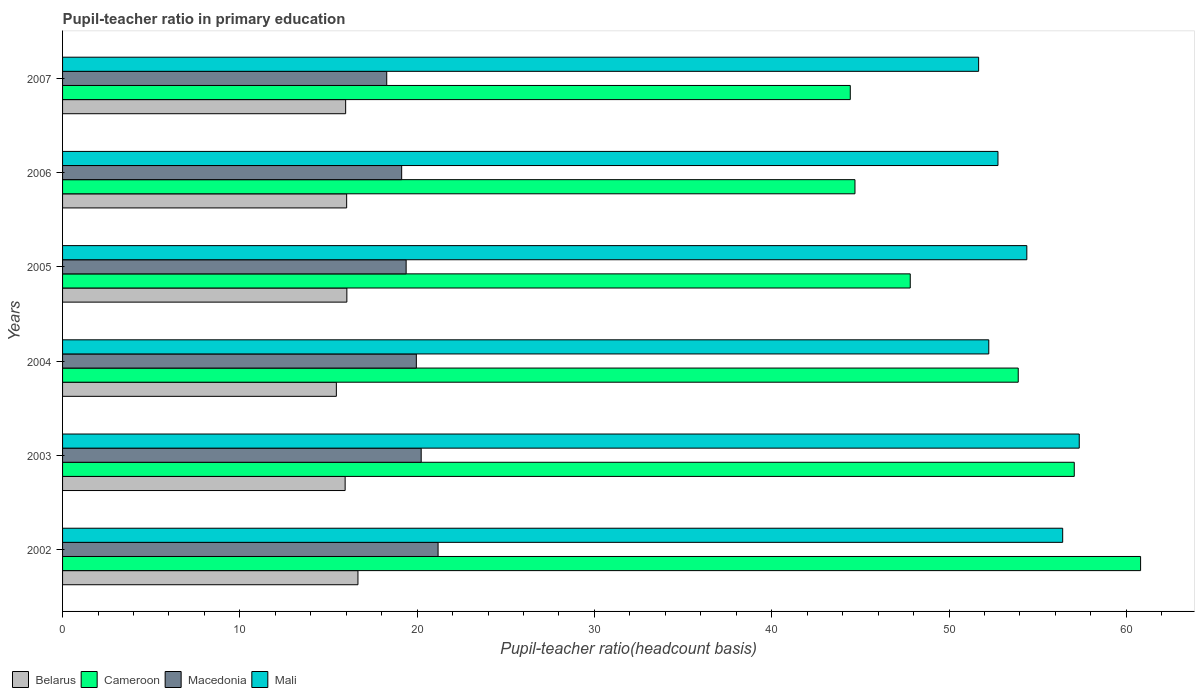How many different coloured bars are there?
Your answer should be compact. 4. How many groups of bars are there?
Make the answer very short. 6. How many bars are there on the 1st tick from the top?
Make the answer very short. 4. How many bars are there on the 3rd tick from the bottom?
Your response must be concise. 4. What is the label of the 6th group of bars from the top?
Keep it short and to the point. 2002. In how many cases, is the number of bars for a given year not equal to the number of legend labels?
Offer a very short reply. 0. What is the pupil-teacher ratio in primary education in Belarus in 2007?
Your answer should be very brief. 15.97. Across all years, what is the maximum pupil-teacher ratio in primary education in Mali?
Ensure brevity in your answer.  57.34. Across all years, what is the minimum pupil-teacher ratio in primary education in Macedonia?
Your response must be concise. 18.28. What is the total pupil-teacher ratio in primary education in Belarus in the graph?
Keep it short and to the point. 96.07. What is the difference between the pupil-teacher ratio in primary education in Cameroon in 2002 and that in 2004?
Your answer should be very brief. 6.9. What is the difference between the pupil-teacher ratio in primary education in Mali in 2004 and the pupil-teacher ratio in primary education in Cameroon in 2005?
Give a very brief answer. 4.43. What is the average pupil-teacher ratio in primary education in Cameroon per year?
Make the answer very short. 51.45. In the year 2004, what is the difference between the pupil-teacher ratio in primary education in Mali and pupil-teacher ratio in primary education in Belarus?
Your answer should be compact. 36.8. In how many years, is the pupil-teacher ratio in primary education in Belarus greater than 22 ?
Your response must be concise. 0. What is the ratio of the pupil-teacher ratio in primary education in Macedonia in 2002 to that in 2003?
Make the answer very short. 1.05. What is the difference between the highest and the second highest pupil-teacher ratio in primary education in Mali?
Offer a terse response. 0.93. What is the difference between the highest and the lowest pupil-teacher ratio in primary education in Mali?
Your answer should be very brief. 5.68. Is it the case that in every year, the sum of the pupil-teacher ratio in primary education in Cameroon and pupil-teacher ratio in primary education in Macedonia is greater than the sum of pupil-teacher ratio in primary education in Belarus and pupil-teacher ratio in primary education in Mali?
Give a very brief answer. Yes. What does the 1st bar from the top in 2003 represents?
Your response must be concise. Mali. What does the 2nd bar from the bottom in 2003 represents?
Your answer should be very brief. Cameroon. Is it the case that in every year, the sum of the pupil-teacher ratio in primary education in Macedonia and pupil-teacher ratio in primary education in Cameroon is greater than the pupil-teacher ratio in primary education in Mali?
Provide a short and direct response. Yes. What is the difference between two consecutive major ticks on the X-axis?
Offer a very short reply. 10. Are the values on the major ticks of X-axis written in scientific E-notation?
Provide a short and direct response. No. Does the graph contain any zero values?
Your answer should be very brief. No. How many legend labels are there?
Ensure brevity in your answer.  4. How are the legend labels stacked?
Ensure brevity in your answer.  Horizontal. What is the title of the graph?
Provide a succinct answer. Pupil-teacher ratio in primary education. Does "Comoros" appear as one of the legend labels in the graph?
Offer a very short reply. No. What is the label or title of the X-axis?
Keep it short and to the point. Pupil-teacher ratio(headcount basis). What is the label or title of the Y-axis?
Make the answer very short. Years. What is the Pupil-teacher ratio(headcount basis) of Belarus in 2002?
Your response must be concise. 16.66. What is the Pupil-teacher ratio(headcount basis) in Cameroon in 2002?
Offer a terse response. 60.8. What is the Pupil-teacher ratio(headcount basis) in Macedonia in 2002?
Give a very brief answer. 21.18. What is the Pupil-teacher ratio(headcount basis) of Mali in 2002?
Give a very brief answer. 56.41. What is the Pupil-teacher ratio(headcount basis) of Belarus in 2003?
Offer a terse response. 15.94. What is the Pupil-teacher ratio(headcount basis) in Cameroon in 2003?
Your answer should be very brief. 57.06. What is the Pupil-teacher ratio(headcount basis) in Macedonia in 2003?
Your answer should be very brief. 20.23. What is the Pupil-teacher ratio(headcount basis) in Mali in 2003?
Give a very brief answer. 57.34. What is the Pupil-teacher ratio(headcount basis) of Belarus in 2004?
Provide a succinct answer. 15.44. What is the Pupil-teacher ratio(headcount basis) of Cameroon in 2004?
Provide a short and direct response. 53.9. What is the Pupil-teacher ratio(headcount basis) in Macedonia in 2004?
Offer a very short reply. 19.95. What is the Pupil-teacher ratio(headcount basis) of Mali in 2004?
Offer a terse response. 52.24. What is the Pupil-teacher ratio(headcount basis) in Belarus in 2005?
Make the answer very short. 16.04. What is the Pupil-teacher ratio(headcount basis) in Cameroon in 2005?
Your response must be concise. 47.81. What is the Pupil-teacher ratio(headcount basis) of Macedonia in 2005?
Offer a very short reply. 19.38. What is the Pupil-teacher ratio(headcount basis) in Mali in 2005?
Provide a short and direct response. 54.39. What is the Pupil-teacher ratio(headcount basis) of Belarus in 2006?
Your response must be concise. 16.02. What is the Pupil-teacher ratio(headcount basis) of Cameroon in 2006?
Make the answer very short. 44.69. What is the Pupil-teacher ratio(headcount basis) in Macedonia in 2006?
Offer a very short reply. 19.13. What is the Pupil-teacher ratio(headcount basis) in Mali in 2006?
Offer a terse response. 52.76. What is the Pupil-teacher ratio(headcount basis) in Belarus in 2007?
Provide a short and direct response. 15.97. What is the Pupil-teacher ratio(headcount basis) in Cameroon in 2007?
Your response must be concise. 44.43. What is the Pupil-teacher ratio(headcount basis) of Macedonia in 2007?
Keep it short and to the point. 18.28. What is the Pupil-teacher ratio(headcount basis) in Mali in 2007?
Make the answer very short. 51.67. Across all years, what is the maximum Pupil-teacher ratio(headcount basis) in Belarus?
Ensure brevity in your answer.  16.66. Across all years, what is the maximum Pupil-teacher ratio(headcount basis) of Cameroon?
Provide a short and direct response. 60.8. Across all years, what is the maximum Pupil-teacher ratio(headcount basis) of Macedonia?
Make the answer very short. 21.18. Across all years, what is the maximum Pupil-teacher ratio(headcount basis) in Mali?
Provide a short and direct response. 57.34. Across all years, what is the minimum Pupil-teacher ratio(headcount basis) in Belarus?
Provide a short and direct response. 15.44. Across all years, what is the minimum Pupil-teacher ratio(headcount basis) of Cameroon?
Keep it short and to the point. 44.43. Across all years, what is the minimum Pupil-teacher ratio(headcount basis) in Macedonia?
Provide a short and direct response. 18.28. Across all years, what is the minimum Pupil-teacher ratio(headcount basis) in Mali?
Your answer should be compact. 51.67. What is the total Pupil-teacher ratio(headcount basis) in Belarus in the graph?
Offer a very short reply. 96.07. What is the total Pupil-teacher ratio(headcount basis) in Cameroon in the graph?
Keep it short and to the point. 308.71. What is the total Pupil-teacher ratio(headcount basis) in Macedonia in the graph?
Your answer should be very brief. 118.15. What is the total Pupil-teacher ratio(headcount basis) of Mali in the graph?
Give a very brief answer. 324.81. What is the difference between the Pupil-teacher ratio(headcount basis) of Belarus in 2002 and that in 2003?
Provide a short and direct response. 0.72. What is the difference between the Pupil-teacher ratio(headcount basis) of Cameroon in 2002 and that in 2003?
Keep it short and to the point. 3.74. What is the difference between the Pupil-teacher ratio(headcount basis) in Macedonia in 2002 and that in 2003?
Provide a succinct answer. 0.95. What is the difference between the Pupil-teacher ratio(headcount basis) in Mali in 2002 and that in 2003?
Make the answer very short. -0.93. What is the difference between the Pupil-teacher ratio(headcount basis) of Belarus in 2002 and that in 2004?
Your response must be concise. 1.22. What is the difference between the Pupil-teacher ratio(headcount basis) of Cameroon in 2002 and that in 2004?
Your answer should be compact. 6.9. What is the difference between the Pupil-teacher ratio(headcount basis) in Macedonia in 2002 and that in 2004?
Provide a short and direct response. 1.23. What is the difference between the Pupil-teacher ratio(headcount basis) of Mali in 2002 and that in 2004?
Offer a very short reply. 4.17. What is the difference between the Pupil-teacher ratio(headcount basis) of Belarus in 2002 and that in 2005?
Provide a succinct answer. 0.63. What is the difference between the Pupil-teacher ratio(headcount basis) in Cameroon in 2002 and that in 2005?
Your answer should be very brief. 12.99. What is the difference between the Pupil-teacher ratio(headcount basis) in Macedonia in 2002 and that in 2005?
Provide a short and direct response. 1.8. What is the difference between the Pupil-teacher ratio(headcount basis) in Mali in 2002 and that in 2005?
Your answer should be compact. 2.02. What is the difference between the Pupil-teacher ratio(headcount basis) of Belarus in 2002 and that in 2006?
Make the answer very short. 0.64. What is the difference between the Pupil-teacher ratio(headcount basis) of Cameroon in 2002 and that in 2006?
Offer a very short reply. 16.11. What is the difference between the Pupil-teacher ratio(headcount basis) of Macedonia in 2002 and that in 2006?
Provide a short and direct response. 2.05. What is the difference between the Pupil-teacher ratio(headcount basis) in Mali in 2002 and that in 2006?
Offer a terse response. 3.65. What is the difference between the Pupil-teacher ratio(headcount basis) of Belarus in 2002 and that in 2007?
Your answer should be compact. 0.69. What is the difference between the Pupil-teacher ratio(headcount basis) in Cameroon in 2002 and that in 2007?
Keep it short and to the point. 16.37. What is the difference between the Pupil-teacher ratio(headcount basis) in Macedonia in 2002 and that in 2007?
Provide a succinct answer. 2.9. What is the difference between the Pupil-teacher ratio(headcount basis) in Mali in 2002 and that in 2007?
Make the answer very short. 4.74. What is the difference between the Pupil-teacher ratio(headcount basis) in Belarus in 2003 and that in 2004?
Make the answer very short. 0.5. What is the difference between the Pupil-teacher ratio(headcount basis) in Cameroon in 2003 and that in 2004?
Your answer should be compact. 3.16. What is the difference between the Pupil-teacher ratio(headcount basis) in Macedonia in 2003 and that in 2004?
Ensure brevity in your answer.  0.27. What is the difference between the Pupil-teacher ratio(headcount basis) in Mali in 2003 and that in 2004?
Your response must be concise. 5.1. What is the difference between the Pupil-teacher ratio(headcount basis) of Belarus in 2003 and that in 2005?
Your answer should be very brief. -0.1. What is the difference between the Pupil-teacher ratio(headcount basis) in Cameroon in 2003 and that in 2005?
Keep it short and to the point. 9.25. What is the difference between the Pupil-teacher ratio(headcount basis) in Macedonia in 2003 and that in 2005?
Your answer should be compact. 0.85. What is the difference between the Pupil-teacher ratio(headcount basis) of Mali in 2003 and that in 2005?
Ensure brevity in your answer.  2.96. What is the difference between the Pupil-teacher ratio(headcount basis) in Belarus in 2003 and that in 2006?
Provide a short and direct response. -0.09. What is the difference between the Pupil-teacher ratio(headcount basis) of Cameroon in 2003 and that in 2006?
Your answer should be very brief. 12.37. What is the difference between the Pupil-teacher ratio(headcount basis) in Macedonia in 2003 and that in 2006?
Make the answer very short. 1.1. What is the difference between the Pupil-teacher ratio(headcount basis) of Mali in 2003 and that in 2006?
Give a very brief answer. 4.58. What is the difference between the Pupil-teacher ratio(headcount basis) of Belarus in 2003 and that in 2007?
Provide a short and direct response. -0.03. What is the difference between the Pupil-teacher ratio(headcount basis) of Cameroon in 2003 and that in 2007?
Offer a very short reply. 12.63. What is the difference between the Pupil-teacher ratio(headcount basis) in Macedonia in 2003 and that in 2007?
Ensure brevity in your answer.  1.94. What is the difference between the Pupil-teacher ratio(headcount basis) of Mali in 2003 and that in 2007?
Your answer should be very brief. 5.68. What is the difference between the Pupil-teacher ratio(headcount basis) in Belarus in 2004 and that in 2005?
Ensure brevity in your answer.  -0.59. What is the difference between the Pupil-teacher ratio(headcount basis) of Cameroon in 2004 and that in 2005?
Your response must be concise. 6.09. What is the difference between the Pupil-teacher ratio(headcount basis) of Macedonia in 2004 and that in 2005?
Give a very brief answer. 0.58. What is the difference between the Pupil-teacher ratio(headcount basis) of Mali in 2004 and that in 2005?
Offer a very short reply. -2.15. What is the difference between the Pupil-teacher ratio(headcount basis) of Belarus in 2004 and that in 2006?
Offer a terse response. -0.58. What is the difference between the Pupil-teacher ratio(headcount basis) of Cameroon in 2004 and that in 2006?
Provide a short and direct response. 9.21. What is the difference between the Pupil-teacher ratio(headcount basis) of Macedonia in 2004 and that in 2006?
Make the answer very short. 0.83. What is the difference between the Pupil-teacher ratio(headcount basis) in Mali in 2004 and that in 2006?
Ensure brevity in your answer.  -0.52. What is the difference between the Pupil-teacher ratio(headcount basis) of Belarus in 2004 and that in 2007?
Your answer should be compact. -0.52. What is the difference between the Pupil-teacher ratio(headcount basis) of Cameroon in 2004 and that in 2007?
Your answer should be very brief. 9.47. What is the difference between the Pupil-teacher ratio(headcount basis) in Macedonia in 2004 and that in 2007?
Your response must be concise. 1.67. What is the difference between the Pupil-teacher ratio(headcount basis) in Mali in 2004 and that in 2007?
Provide a short and direct response. 0.57. What is the difference between the Pupil-teacher ratio(headcount basis) in Belarus in 2005 and that in 2006?
Give a very brief answer. 0.01. What is the difference between the Pupil-teacher ratio(headcount basis) in Cameroon in 2005 and that in 2006?
Keep it short and to the point. 3.12. What is the difference between the Pupil-teacher ratio(headcount basis) of Macedonia in 2005 and that in 2006?
Provide a succinct answer. 0.25. What is the difference between the Pupil-teacher ratio(headcount basis) of Mali in 2005 and that in 2006?
Keep it short and to the point. 1.63. What is the difference between the Pupil-teacher ratio(headcount basis) of Belarus in 2005 and that in 2007?
Your answer should be compact. 0.07. What is the difference between the Pupil-teacher ratio(headcount basis) in Cameroon in 2005 and that in 2007?
Your answer should be compact. 3.38. What is the difference between the Pupil-teacher ratio(headcount basis) in Macedonia in 2005 and that in 2007?
Ensure brevity in your answer.  1.09. What is the difference between the Pupil-teacher ratio(headcount basis) of Mali in 2005 and that in 2007?
Ensure brevity in your answer.  2.72. What is the difference between the Pupil-teacher ratio(headcount basis) in Belarus in 2006 and that in 2007?
Your response must be concise. 0.06. What is the difference between the Pupil-teacher ratio(headcount basis) in Cameroon in 2006 and that in 2007?
Offer a very short reply. 0.26. What is the difference between the Pupil-teacher ratio(headcount basis) of Macedonia in 2006 and that in 2007?
Your answer should be very brief. 0.84. What is the difference between the Pupil-teacher ratio(headcount basis) in Mali in 2006 and that in 2007?
Provide a short and direct response. 1.09. What is the difference between the Pupil-teacher ratio(headcount basis) of Belarus in 2002 and the Pupil-teacher ratio(headcount basis) of Cameroon in 2003?
Keep it short and to the point. -40.4. What is the difference between the Pupil-teacher ratio(headcount basis) in Belarus in 2002 and the Pupil-teacher ratio(headcount basis) in Macedonia in 2003?
Keep it short and to the point. -3.57. What is the difference between the Pupil-teacher ratio(headcount basis) in Belarus in 2002 and the Pupil-teacher ratio(headcount basis) in Mali in 2003?
Make the answer very short. -40.68. What is the difference between the Pupil-teacher ratio(headcount basis) of Cameroon in 2002 and the Pupil-teacher ratio(headcount basis) of Macedonia in 2003?
Your response must be concise. 40.58. What is the difference between the Pupil-teacher ratio(headcount basis) of Cameroon in 2002 and the Pupil-teacher ratio(headcount basis) of Mali in 2003?
Offer a terse response. 3.46. What is the difference between the Pupil-teacher ratio(headcount basis) in Macedonia in 2002 and the Pupil-teacher ratio(headcount basis) in Mali in 2003?
Make the answer very short. -36.16. What is the difference between the Pupil-teacher ratio(headcount basis) of Belarus in 2002 and the Pupil-teacher ratio(headcount basis) of Cameroon in 2004?
Offer a very short reply. -37.24. What is the difference between the Pupil-teacher ratio(headcount basis) in Belarus in 2002 and the Pupil-teacher ratio(headcount basis) in Macedonia in 2004?
Ensure brevity in your answer.  -3.29. What is the difference between the Pupil-teacher ratio(headcount basis) of Belarus in 2002 and the Pupil-teacher ratio(headcount basis) of Mali in 2004?
Provide a short and direct response. -35.58. What is the difference between the Pupil-teacher ratio(headcount basis) in Cameroon in 2002 and the Pupil-teacher ratio(headcount basis) in Macedonia in 2004?
Your response must be concise. 40.85. What is the difference between the Pupil-teacher ratio(headcount basis) of Cameroon in 2002 and the Pupil-teacher ratio(headcount basis) of Mali in 2004?
Provide a succinct answer. 8.56. What is the difference between the Pupil-teacher ratio(headcount basis) in Macedonia in 2002 and the Pupil-teacher ratio(headcount basis) in Mali in 2004?
Offer a very short reply. -31.06. What is the difference between the Pupil-teacher ratio(headcount basis) of Belarus in 2002 and the Pupil-teacher ratio(headcount basis) of Cameroon in 2005?
Keep it short and to the point. -31.15. What is the difference between the Pupil-teacher ratio(headcount basis) in Belarus in 2002 and the Pupil-teacher ratio(headcount basis) in Macedonia in 2005?
Offer a very short reply. -2.72. What is the difference between the Pupil-teacher ratio(headcount basis) in Belarus in 2002 and the Pupil-teacher ratio(headcount basis) in Mali in 2005?
Make the answer very short. -37.73. What is the difference between the Pupil-teacher ratio(headcount basis) in Cameroon in 2002 and the Pupil-teacher ratio(headcount basis) in Macedonia in 2005?
Make the answer very short. 41.43. What is the difference between the Pupil-teacher ratio(headcount basis) of Cameroon in 2002 and the Pupil-teacher ratio(headcount basis) of Mali in 2005?
Your answer should be compact. 6.42. What is the difference between the Pupil-teacher ratio(headcount basis) of Macedonia in 2002 and the Pupil-teacher ratio(headcount basis) of Mali in 2005?
Ensure brevity in your answer.  -33.21. What is the difference between the Pupil-teacher ratio(headcount basis) in Belarus in 2002 and the Pupil-teacher ratio(headcount basis) in Cameroon in 2006?
Keep it short and to the point. -28.03. What is the difference between the Pupil-teacher ratio(headcount basis) in Belarus in 2002 and the Pupil-teacher ratio(headcount basis) in Macedonia in 2006?
Keep it short and to the point. -2.47. What is the difference between the Pupil-teacher ratio(headcount basis) of Belarus in 2002 and the Pupil-teacher ratio(headcount basis) of Mali in 2006?
Your answer should be very brief. -36.1. What is the difference between the Pupil-teacher ratio(headcount basis) in Cameroon in 2002 and the Pupil-teacher ratio(headcount basis) in Macedonia in 2006?
Provide a succinct answer. 41.68. What is the difference between the Pupil-teacher ratio(headcount basis) in Cameroon in 2002 and the Pupil-teacher ratio(headcount basis) in Mali in 2006?
Ensure brevity in your answer.  8.04. What is the difference between the Pupil-teacher ratio(headcount basis) of Macedonia in 2002 and the Pupil-teacher ratio(headcount basis) of Mali in 2006?
Your response must be concise. -31.58. What is the difference between the Pupil-teacher ratio(headcount basis) of Belarus in 2002 and the Pupil-teacher ratio(headcount basis) of Cameroon in 2007?
Your answer should be very brief. -27.77. What is the difference between the Pupil-teacher ratio(headcount basis) in Belarus in 2002 and the Pupil-teacher ratio(headcount basis) in Macedonia in 2007?
Your response must be concise. -1.62. What is the difference between the Pupil-teacher ratio(headcount basis) of Belarus in 2002 and the Pupil-teacher ratio(headcount basis) of Mali in 2007?
Your response must be concise. -35.01. What is the difference between the Pupil-teacher ratio(headcount basis) of Cameroon in 2002 and the Pupil-teacher ratio(headcount basis) of Macedonia in 2007?
Your response must be concise. 42.52. What is the difference between the Pupil-teacher ratio(headcount basis) of Cameroon in 2002 and the Pupil-teacher ratio(headcount basis) of Mali in 2007?
Make the answer very short. 9.14. What is the difference between the Pupil-teacher ratio(headcount basis) in Macedonia in 2002 and the Pupil-teacher ratio(headcount basis) in Mali in 2007?
Keep it short and to the point. -30.49. What is the difference between the Pupil-teacher ratio(headcount basis) in Belarus in 2003 and the Pupil-teacher ratio(headcount basis) in Cameroon in 2004?
Your answer should be compact. -37.96. What is the difference between the Pupil-teacher ratio(headcount basis) of Belarus in 2003 and the Pupil-teacher ratio(headcount basis) of Macedonia in 2004?
Your response must be concise. -4.02. What is the difference between the Pupil-teacher ratio(headcount basis) in Belarus in 2003 and the Pupil-teacher ratio(headcount basis) in Mali in 2004?
Ensure brevity in your answer.  -36.3. What is the difference between the Pupil-teacher ratio(headcount basis) in Cameroon in 2003 and the Pupil-teacher ratio(headcount basis) in Macedonia in 2004?
Your answer should be compact. 37.11. What is the difference between the Pupil-teacher ratio(headcount basis) in Cameroon in 2003 and the Pupil-teacher ratio(headcount basis) in Mali in 2004?
Your answer should be compact. 4.82. What is the difference between the Pupil-teacher ratio(headcount basis) in Macedonia in 2003 and the Pupil-teacher ratio(headcount basis) in Mali in 2004?
Keep it short and to the point. -32.01. What is the difference between the Pupil-teacher ratio(headcount basis) in Belarus in 2003 and the Pupil-teacher ratio(headcount basis) in Cameroon in 2005?
Provide a succinct answer. -31.87. What is the difference between the Pupil-teacher ratio(headcount basis) of Belarus in 2003 and the Pupil-teacher ratio(headcount basis) of Macedonia in 2005?
Provide a succinct answer. -3.44. What is the difference between the Pupil-teacher ratio(headcount basis) of Belarus in 2003 and the Pupil-teacher ratio(headcount basis) of Mali in 2005?
Give a very brief answer. -38.45. What is the difference between the Pupil-teacher ratio(headcount basis) in Cameroon in 2003 and the Pupil-teacher ratio(headcount basis) in Macedonia in 2005?
Your response must be concise. 37.69. What is the difference between the Pupil-teacher ratio(headcount basis) in Cameroon in 2003 and the Pupil-teacher ratio(headcount basis) in Mali in 2005?
Offer a terse response. 2.68. What is the difference between the Pupil-teacher ratio(headcount basis) of Macedonia in 2003 and the Pupil-teacher ratio(headcount basis) of Mali in 2005?
Offer a very short reply. -34.16. What is the difference between the Pupil-teacher ratio(headcount basis) in Belarus in 2003 and the Pupil-teacher ratio(headcount basis) in Cameroon in 2006?
Your answer should be very brief. -28.76. What is the difference between the Pupil-teacher ratio(headcount basis) in Belarus in 2003 and the Pupil-teacher ratio(headcount basis) in Macedonia in 2006?
Your response must be concise. -3.19. What is the difference between the Pupil-teacher ratio(headcount basis) of Belarus in 2003 and the Pupil-teacher ratio(headcount basis) of Mali in 2006?
Your response must be concise. -36.82. What is the difference between the Pupil-teacher ratio(headcount basis) of Cameroon in 2003 and the Pupil-teacher ratio(headcount basis) of Macedonia in 2006?
Keep it short and to the point. 37.94. What is the difference between the Pupil-teacher ratio(headcount basis) in Cameroon in 2003 and the Pupil-teacher ratio(headcount basis) in Mali in 2006?
Keep it short and to the point. 4.3. What is the difference between the Pupil-teacher ratio(headcount basis) of Macedonia in 2003 and the Pupil-teacher ratio(headcount basis) of Mali in 2006?
Your response must be concise. -32.53. What is the difference between the Pupil-teacher ratio(headcount basis) of Belarus in 2003 and the Pupil-teacher ratio(headcount basis) of Cameroon in 2007?
Ensure brevity in your answer.  -28.49. What is the difference between the Pupil-teacher ratio(headcount basis) of Belarus in 2003 and the Pupil-teacher ratio(headcount basis) of Macedonia in 2007?
Keep it short and to the point. -2.35. What is the difference between the Pupil-teacher ratio(headcount basis) in Belarus in 2003 and the Pupil-teacher ratio(headcount basis) in Mali in 2007?
Provide a succinct answer. -35.73. What is the difference between the Pupil-teacher ratio(headcount basis) in Cameroon in 2003 and the Pupil-teacher ratio(headcount basis) in Macedonia in 2007?
Offer a very short reply. 38.78. What is the difference between the Pupil-teacher ratio(headcount basis) in Cameroon in 2003 and the Pupil-teacher ratio(headcount basis) in Mali in 2007?
Your answer should be very brief. 5.39. What is the difference between the Pupil-teacher ratio(headcount basis) of Macedonia in 2003 and the Pupil-teacher ratio(headcount basis) of Mali in 2007?
Provide a short and direct response. -31.44. What is the difference between the Pupil-teacher ratio(headcount basis) of Belarus in 2004 and the Pupil-teacher ratio(headcount basis) of Cameroon in 2005?
Your answer should be very brief. -32.37. What is the difference between the Pupil-teacher ratio(headcount basis) of Belarus in 2004 and the Pupil-teacher ratio(headcount basis) of Macedonia in 2005?
Keep it short and to the point. -3.94. What is the difference between the Pupil-teacher ratio(headcount basis) of Belarus in 2004 and the Pupil-teacher ratio(headcount basis) of Mali in 2005?
Make the answer very short. -38.95. What is the difference between the Pupil-teacher ratio(headcount basis) in Cameroon in 2004 and the Pupil-teacher ratio(headcount basis) in Macedonia in 2005?
Keep it short and to the point. 34.52. What is the difference between the Pupil-teacher ratio(headcount basis) in Cameroon in 2004 and the Pupil-teacher ratio(headcount basis) in Mali in 2005?
Your answer should be very brief. -0.49. What is the difference between the Pupil-teacher ratio(headcount basis) of Macedonia in 2004 and the Pupil-teacher ratio(headcount basis) of Mali in 2005?
Offer a terse response. -34.43. What is the difference between the Pupil-teacher ratio(headcount basis) of Belarus in 2004 and the Pupil-teacher ratio(headcount basis) of Cameroon in 2006?
Your answer should be very brief. -29.25. What is the difference between the Pupil-teacher ratio(headcount basis) in Belarus in 2004 and the Pupil-teacher ratio(headcount basis) in Macedonia in 2006?
Your answer should be very brief. -3.68. What is the difference between the Pupil-teacher ratio(headcount basis) of Belarus in 2004 and the Pupil-teacher ratio(headcount basis) of Mali in 2006?
Offer a terse response. -37.32. What is the difference between the Pupil-teacher ratio(headcount basis) in Cameroon in 2004 and the Pupil-teacher ratio(headcount basis) in Macedonia in 2006?
Give a very brief answer. 34.78. What is the difference between the Pupil-teacher ratio(headcount basis) of Cameroon in 2004 and the Pupil-teacher ratio(headcount basis) of Mali in 2006?
Your response must be concise. 1.14. What is the difference between the Pupil-teacher ratio(headcount basis) in Macedonia in 2004 and the Pupil-teacher ratio(headcount basis) in Mali in 2006?
Your answer should be compact. -32.81. What is the difference between the Pupil-teacher ratio(headcount basis) of Belarus in 2004 and the Pupil-teacher ratio(headcount basis) of Cameroon in 2007?
Provide a succinct answer. -28.99. What is the difference between the Pupil-teacher ratio(headcount basis) of Belarus in 2004 and the Pupil-teacher ratio(headcount basis) of Macedonia in 2007?
Provide a short and direct response. -2.84. What is the difference between the Pupil-teacher ratio(headcount basis) in Belarus in 2004 and the Pupil-teacher ratio(headcount basis) in Mali in 2007?
Give a very brief answer. -36.23. What is the difference between the Pupil-teacher ratio(headcount basis) of Cameroon in 2004 and the Pupil-teacher ratio(headcount basis) of Macedonia in 2007?
Your response must be concise. 35.62. What is the difference between the Pupil-teacher ratio(headcount basis) in Cameroon in 2004 and the Pupil-teacher ratio(headcount basis) in Mali in 2007?
Ensure brevity in your answer.  2.23. What is the difference between the Pupil-teacher ratio(headcount basis) of Macedonia in 2004 and the Pupil-teacher ratio(headcount basis) of Mali in 2007?
Provide a succinct answer. -31.71. What is the difference between the Pupil-teacher ratio(headcount basis) of Belarus in 2005 and the Pupil-teacher ratio(headcount basis) of Cameroon in 2006?
Provide a short and direct response. -28.66. What is the difference between the Pupil-teacher ratio(headcount basis) in Belarus in 2005 and the Pupil-teacher ratio(headcount basis) in Macedonia in 2006?
Your answer should be very brief. -3.09. What is the difference between the Pupil-teacher ratio(headcount basis) of Belarus in 2005 and the Pupil-teacher ratio(headcount basis) of Mali in 2006?
Provide a succinct answer. -36.72. What is the difference between the Pupil-teacher ratio(headcount basis) of Cameroon in 2005 and the Pupil-teacher ratio(headcount basis) of Macedonia in 2006?
Give a very brief answer. 28.69. What is the difference between the Pupil-teacher ratio(headcount basis) of Cameroon in 2005 and the Pupil-teacher ratio(headcount basis) of Mali in 2006?
Provide a short and direct response. -4.95. What is the difference between the Pupil-teacher ratio(headcount basis) of Macedonia in 2005 and the Pupil-teacher ratio(headcount basis) of Mali in 2006?
Provide a succinct answer. -33.38. What is the difference between the Pupil-teacher ratio(headcount basis) of Belarus in 2005 and the Pupil-teacher ratio(headcount basis) of Cameroon in 2007?
Provide a succinct answer. -28.39. What is the difference between the Pupil-teacher ratio(headcount basis) of Belarus in 2005 and the Pupil-teacher ratio(headcount basis) of Macedonia in 2007?
Give a very brief answer. -2.25. What is the difference between the Pupil-teacher ratio(headcount basis) in Belarus in 2005 and the Pupil-teacher ratio(headcount basis) in Mali in 2007?
Your answer should be very brief. -35.63. What is the difference between the Pupil-teacher ratio(headcount basis) of Cameroon in 2005 and the Pupil-teacher ratio(headcount basis) of Macedonia in 2007?
Provide a short and direct response. 29.53. What is the difference between the Pupil-teacher ratio(headcount basis) of Cameroon in 2005 and the Pupil-teacher ratio(headcount basis) of Mali in 2007?
Offer a very short reply. -3.86. What is the difference between the Pupil-teacher ratio(headcount basis) in Macedonia in 2005 and the Pupil-teacher ratio(headcount basis) in Mali in 2007?
Offer a terse response. -32.29. What is the difference between the Pupil-teacher ratio(headcount basis) of Belarus in 2006 and the Pupil-teacher ratio(headcount basis) of Cameroon in 2007?
Your answer should be compact. -28.41. What is the difference between the Pupil-teacher ratio(headcount basis) in Belarus in 2006 and the Pupil-teacher ratio(headcount basis) in Macedonia in 2007?
Your answer should be very brief. -2.26. What is the difference between the Pupil-teacher ratio(headcount basis) of Belarus in 2006 and the Pupil-teacher ratio(headcount basis) of Mali in 2007?
Offer a very short reply. -35.64. What is the difference between the Pupil-teacher ratio(headcount basis) of Cameroon in 2006 and the Pupil-teacher ratio(headcount basis) of Macedonia in 2007?
Your answer should be very brief. 26.41. What is the difference between the Pupil-teacher ratio(headcount basis) of Cameroon in 2006 and the Pupil-teacher ratio(headcount basis) of Mali in 2007?
Provide a succinct answer. -6.97. What is the difference between the Pupil-teacher ratio(headcount basis) in Macedonia in 2006 and the Pupil-teacher ratio(headcount basis) in Mali in 2007?
Ensure brevity in your answer.  -32.54. What is the average Pupil-teacher ratio(headcount basis) of Belarus per year?
Provide a short and direct response. 16.01. What is the average Pupil-teacher ratio(headcount basis) in Cameroon per year?
Keep it short and to the point. 51.45. What is the average Pupil-teacher ratio(headcount basis) in Macedonia per year?
Your answer should be very brief. 19.69. What is the average Pupil-teacher ratio(headcount basis) in Mali per year?
Your answer should be very brief. 54.14. In the year 2002, what is the difference between the Pupil-teacher ratio(headcount basis) in Belarus and Pupil-teacher ratio(headcount basis) in Cameroon?
Your response must be concise. -44.14. In the year 2002, what is the difference between the Pupil-teacher ratio(headcount basis) in Belarus and Pupil-teacher ratio(headcount basis) in Macedonia?
Your response must be concise. -4.52. In the year 2002, what is the difference between the Pupil-teacher ratio(headcount basis) of Belarus and Pupil-teacher ratio(headcount basis) of Mali?
Make the answer very short. -39.75. In the year 2002, what is the difference between the Pupil-teacher ratio(headcount basis) in Cameroon and Pupil-teacher ratio(headcount basis) in Macedonia?
Offer a very short reply. 39.62. In the year 2002, what is the difference between the Pupil-teacher ratio(headcount basis) of Cameroon and Pupil-teacher ratio(headcount basis) of Mali?
Offer a terse response. 4.39. In the year 2002, what is the difference between the Pupil-teacher ratio(headcount basis) in Macedonia and Pupil-teacher ratio(headcount basis) in Mali?
Keep it short and to the point. -35.23. In the year 2003, what is the difference between the Pupil-teacher ratio(headcount basis) in Belarus and Pupil-teacher ratio(headcount basis) in Cameroon?
Ensure brevity in your answer.  -41.13. In the year 2003, what is the difference between the Pupil-teacher ratio(headcount basis) of Belarus and Pupil-teacher ratio(headcount basis) of Macedonia?
Provide a succinct answer. -4.29. In the year 2003, what is the difference between the Pupil-teacher ratio(headcount basis) of Belarus and Pupil-teacher ratio(headcount basis) of Mali?
Provide a short and direct response. -41.41. In the year 2003, what is the difference between the Pupil-teacher ratio(headcount basis) of Cameroon and Pupil-teacher ratio(headcount basis) of Macedonia?
Offer a very short reply. 36.84. In the year 2003, what is the difference between the Pupil-teacher ratio(headcount basis) in Cameroon and Pupil-teacher ratio(headcount basis) in Mali?
Provide a short and direct response. -0.28. In the year 2003, what is the difference between the Pupil-teacher ratio(headcount basis) of Macedonia and Pupil-teacher ratio(headcount basis) of Mali?
Ensure brevity in your answer.  -37.12. In the year 2004, what is the difference between the Pupil-teacher ratio(headcount basis) of Belarus and Pupil-teacher ratio(headcount basis) of Cameroon?
Keep it short and to the point. -38.46. In the year 2004, what is the difference between the Pupil-teacher ratio(headcount basis) in Belarus and Pupil-teacher ratio(headcount basis) in Macedonia?
Provide a short and direct response. -4.51. In the year 2004, what is the difference between the Pupil-teacher ratio(headcount basis) of Belarus and Pupil-teacher ratio(headcount basis) of Mali?
Give a very brief answer. -36.8. In the year 2004, what is the difference between the Pupil-teacher ratio(headcount basis) of Cameroon and Pupil-teacher ratio(headcount basis) of Macedonia?
Provide a succinct answer. 33.95. In the year 2004, what is the difference between the Pupil-teacher ratio(headcount basis) in Cameroon and Pupil-teacher ratio(headcount basis) in Mali?
Provide a short and direct response. 1.66. In the year 2004, what is the difference between the Pupil-teacher ratio(headcount basis) in Macedonia and Pupil-teacher ratio(headcount basis) in Mali?
Keep it short and to the point. -32.29. In the year 2005, what is the difference between the Pupil-teacher ratio(headcount basis) of Belarus and Pupil-teacher ratio(headcount basis) of Cameroon?
Ensure brevity in your answer.  -31.78. In the year 2005, what is the difference between the Pupil-teacher ratio(headcount basis) in Belarus and Pupil-teacher ratio(headcount basis) in Macedonia?
Your answer should be compact. -3.34. In the year 2005, what is the difference between the Pupil-teacher ratio(headcount basis) of Belarus and Pupil-teacher ratio(headcount basis) of Mali?
Make the answer very short. -38.35. In the year 2005, what is the difference between the Pupil-teacher ratio(headcount basis) of Cameroon and Pupil-teacher ratio(headcount basis) of Macedonia?
Provide a short and direct response. 28.43. In the year 2005, what is the difference between the Pupil-teacher ratio(headcount basis) of Cameroon and Pupil-teacher ratio(headcount basis) of Mali?
Your answer should be compact. -6.58. In the year 2005, what is the difference between the Pupil-teacher ratio(headcount basis) of Macedonia and Pupil-teacher ratio(headcount basis) of Mali?
Your answer should be very brief. -35.01. In the year 2006, what is the difference between the Pupil-teacher ratio(headcount basis) in Belarus and Pupil-teacher ratio(headcount basis) in Cameroon?
Give a very brief answer. -28.67. In the year 2006, what is the difference between the Pupil-teacher ratio(headcount basis) in Belarus and Pupil-teacher ratio(headcount basis) in Macedonia?
Provide a short and direct response. -3.1. In the year 2006, what is the difference between the Pupil-teacher ratio(headcount basis) in Belarus and Pupil-teacher ratio(headcount basis) in Mali?
Give a very brief answer. -36.74. In the year 2006, what is the difference between the Pupil-teacher ratio(headcount basis) of Cameroon and Pupil-teacher ratio(headcount basis) of Macedonia?
Offer a very short reply. 25.57. In the year 2006, what is the difference between the Pupil-teacher ratio(headcount basis) in Cameroon and Pupil-teacher ratio(headcount basis) in Mali?
Provide a succinct answer. -8.07. In the year 2006, what is the difference between the Pupil-teacher ratio(headcount basis) in Macedonia and Pupil-teacher ratio(headcount basis) in Mali?
Ensure brevity in your answer.  -33.63. In the year 2007, what is the difference between the Pupil-teacher ratio(headcount basis) in Belarus and Pupil-teacher ratio(headcount basis) in Cameroon?
Your response must be concise. -28.46. In the year 2007, what is the difference between the Pupil-teacher ratio(headcount basis) of Belarus and Pupil-teacher ratio(headcount basis) of Macedonia?
Offer a terse response. -2.32. In the year 2007, what is the difference between the Pupil-teacher ratio(headcount basis) of Belarus and Pupil-teacher ratio(headcount basis) of Mali?
Provide a succinct answer. -35.7. In the year 2007, what is the difference between the Pupil-teacher ratio(headcount basis) in Cameroon and Pupil-teacher ratio(headcount basis) in Macedonia?
Your response must be concise. 26.15. In the year 2007, what is the difference between the Pupil-teacher ratio(headcount basis) of Cameroon and Pupil-teacher ratio(headcount basis) of Mali?
Provide a succinct answer. -7.24. In the year 2007, what is the difference between the Pupil-teacher ratio(headcount basis) in Macedonia and Pupil-teacher ratio(headcount basis) in Mali?
Give a very brief answer. -33.38. What is the ratio of the Pupil-teacher ratio(headcount basis) of Belarus in 2002 to that in 2003?
Ensure brevity in your answer.  1.05. What is the ratio of the Pupil-teacher ratio(headcount basis) of Cameroon in 2002 to that in 2003?
Your answer should be very brief. 1.07. What is the ratio of the Pupil-teacher ratio(headcount basis) in Macedonia in 2002 to that in 2003?
Your answer should be compact. 1.05. What is the ratio of the Pupil-teacher ratio(headcount basis) of Mali in 2002 to that in 2003?
Provide a succinct answer. 0.98. What is the ratio of the Pupil-teacher ratio(headcount basis) in Belarus in 2002 to that in 2004?
Provide a short and direct response. 1.08. What is the ratio of the Pupil-teacher ratio(headcount basis) of Cameroon in 2002 to that in 2004?
Provide a succinct answer. 1.13. What is the ratio of the Pupil-teacher ratio(headcount basis) in Macedonia in 2002 to that in 2004?
Keep it short and to the point. 1.06. What is the ratio of the Pupil-teacher ratio(headcount basis) in Mali in 2002 to that in 2004?
Offer a terse response. 1.08. What is the ratio of the Pupil-teacher ratio(headcount basis) of Belarus in 2002 to that in 2005?
Keep it short and to the point. 1.04. What is the ratio of the Pupil-teacher ratio(headcount basis) of Cameroon in 2002 to that in 2005?
Your answer should be compact. 1.27. What is the ratio of the Pupil-teacher ratio(headcount basis) of Macedonia in 2002 to that in 2005?
Your response must be concise. 1.09. What is the ratio of the Pupil-teacher ratio(headcount basis) in Mali in 2002 to that in 2005?
Make the answer very short. 1.04. What is the ratio of the Pupil-teacher ratio(headcount basis) of Belarus in 2002 to that in 2006?
Provide a short and direct response. 1.04. What is the ratio of the Pupil-teacher ratio(headcount basis) in Cameroon in 2002 to that in 2006?
Provide a short and direct response. 1.36. What is the ratio of the Pupil-teacher ratio(headcount basis) of Macedonia in 2002 to that in 2006?
Your answer should be compact. 1.11. What is the ratio of the Pupil-teacher ratio(headcount basis) of Mali in 2002 to that in 2006?
Ensure brevity in your answer.  1.07. What is the ratio of the Pupil-teacher ratio(headcount basis) of Belarus in 2002 to that in 2007?
Your response must be concise. 1.04. What is the ratio of the Pupil-teacher ratio(headcount basis) of Cameroon in 2002 to that in 2007?
Provide a short and direct response. 1.37. What is the ratio of the Pupil-teacher ratio(headcount basis) in Macedonia in 2002 to that in 2007?
Offer a very short reply. 1.16. What is the ratio of the Pupil-teacher ratio(headcount basis) of Mali in 2002 to that in 2007?
Offer a very short reply. 1.09. What is the ratio of the Pupil-teacher ratio(headcount basis) in Belarus in 2003 to that in 2004?
Provide a succinct answer. 1.03. What is the ratio of the Pupil-teacher ratio(headcount basis) in Cameroon in 2003 to that in 2004?
Your answer should be compact. 1.06. What is the ratio of the Pupil-teacher ratio(headcount basis) in Macedonia in 2003 to that in 2004?
Keep it short and to the point. 1.01. What is the ratio of the Pupil-teacher ratio(headcount basis) in Mali in 2003 to that in 2004?
Provide a succinct answer. 1.1. What is the ratio of the Pupil-teacher ratio(headcount basis) of Belarus in 2003 to that in 2005?
Your answer should be very brief. 0.99. What is the ratio of the Pupil-teacher ratio(headcount basis) of Cameroon in 2003 to that in 2005?
Provide a succinct answer. 1.19. What is the ratio of the Pupil-teacher ratio(headcount basis) in Macedonia in 2003 to that in 2005?
Your response must be concise. 1.04. What is the ratio of the Pupil-teacher ratio(headcount basis) in Mali in 2003 to that in 2005?
Your response must be concise. 1.05. What is the ratio of the Pupil-teacher ratio(headcount basis) of Cameroon in 2003 to that in 2006?
Provide a succinct answer. 1.28. What is the ratio of the Pupil-teacher ratio(headcount basis) in Macedonia in 2003 to that in 2006?
Provide a succinct answer. 1.06. What is the ratio of the Pupil-teacher ratio(headcount basis) of Mali in 2003 to that in 2006?
Your answer should be very brief. 1.09. What is the ratio of the Pupil-teacher ratio(headcount basis) in Cameroon in 2003 to that in 2007?
Make the answer very short. 1.28. What is the ratio of the Pupil-teacher ratio(headcount basis) in Macedonia in 2003 to that in 2007?
Provide a succinct answer. 1.11. What is the ratio of the Pupil-teacher ratio(headcount basis) of Mali in 2003 to that in 2007?
Provide a succinct answer. 1.11. What is the ratio of the Pupil-teacher ratio(headcount basis) in Cameroon in 2004 to that in 2005?
Your response must be concise. 1.13. What is the ratio of the Pupil-teacher ratio(headcount basis) of Macedonia in 2004 to that in 2005?
Give a very brief answer. 1.03. What is the ratio of the Pupil-teacher ratio(headcount basis) in Mali in 2004 to that in 2005?
Provide a succinct answer. 0.96. What is the ratio of the Pupil-teacher ratio(headcount basis) in Belarus in 2004 to that in 2006?
Give a very brief answer. 0.96. What is the ratio of the Pupil-teacher ratio(headcount basis) of Cameroon in 2004 to that in 2006?
Provide a succinct answer. 1.21. What is the ratio of the Pupil-teacher ratio(headcount basis) of Macedonia in 2004 to that in 2006?
Give a very brief answer. 1.04. What is the ratio of the Pupil-teacher ratio(headcount basis) of Mali in 2004 to that in 2006?
Provide a short and direct response. 0.99. What is the ratio of the Pupil-teacher ratio(headcount basis) in Belarus in 2004 to that in 2007?
Your answer should be very brief. 0.97. What is the ratio of the Pupil-teacher ratio(headcount basis) of Cameroon in 2004 to that in 2007?
Provide a short and direct response. 1.21. What is the ratio of the Pupil-teacher ratio(headcount basis) in Macedonia in 2004 to that in 2007?
Your answer should be very brief. 1.09. What is the ratio of the Pupil-teacher ratio(headcount basis) in Mali in 2004 to that in 2007?
Your answer should be very brief. 1.01. What is the ratio of the Pupil-teacher ratio(headcount basis) of Cameroon in 2005 to that in 2006?
Provide a succinct answer. 1.07. What is the ratio of the Pupil-teacher ratio(headcount basis) of Macedonia in 2005 to that in 2006?
Offer a terse response. 1.01. What is the ratio of the Pupil-teacher ratio(headcount basis) in Mali in 2005 to that in 2006?
Provide a succinct answer. 1.03. What is the ratio of the Pupil-teacher ratio(headcount basis) in Belarus in 2005 to that in 2007?
Offer a terse response. 1. What is the ratio of the Pupil-teacher ratio(headcount basis) in Cameroon in 2005 to that in 2007?
Give a very brief answer. 1.08. What is the ratio of the Pupil-teacher ratio(headcount basis) of Macedonia in 2005 to that in 2007?
Your response must be concise. 1.06. What is the ratio of the Pupil-teacher ratio(headcount basis) of Mali in 2005 to that in 2007?
Make the answer very short. 1.05. What is the ratio of the Pupil-teacher ratio(headcount basis) in Belarus in 2006 to that in 2007?
Your answer should be very brief. 1. What is the ratio of the Pupil-teacher ratio(headcount basis) in Cameroon in 2006 to that in 2007?
Your answer should be compact. 1.01. What is the ratio of the Pupil-teacher ratio(headcount basis) of Macedonia in 2006 to that in 2007?
Your answer should be very brief. 1.05. What is the ratio of the Pupil-teacher ratio(headcount basis) in Mali in 2006 to that in 2007?
Provide a short and direct response. 1.02. What is the difference between the highest and the second highest Pupil-teacher ratio(headcount basis) in Belarus?
Keep it short and to the point. 0.63. What is the difference between the highest and the second highest Pupil-teacher ratio(headcount basis) in Cameroon?
Your response must be concise. 3.74. What is the difference between the highest and the second highest Pupil-teacher ratio(headcount basis) of Macedonia?
Your answer should be compact. 0.95. What is the difference between the highest and the second highest Pupil-teacher ratio(headcount basis) in Mali?
Ensure brevity in your answer.  0.93. What is the difference between the highest and the lowest Pupil-teacher ratio(headcount basis) in Belarus?
Keep it short and to the point. 1.22. What is the difference between the highest and the lowest Pupil-teacher ratio(headcount basis) of Cameroon?
Offer a terse response. 16.37. What is the difference between the highest and the lowest Pupil-teacher ratio(headcount basis) of Macedonia?
Your answer should be compact. 2.9. What is the difference between the highest and the lowest Pupil-teacher ratio(headcount basis) of Mali?
Provide a succinct answer. 5.68. 